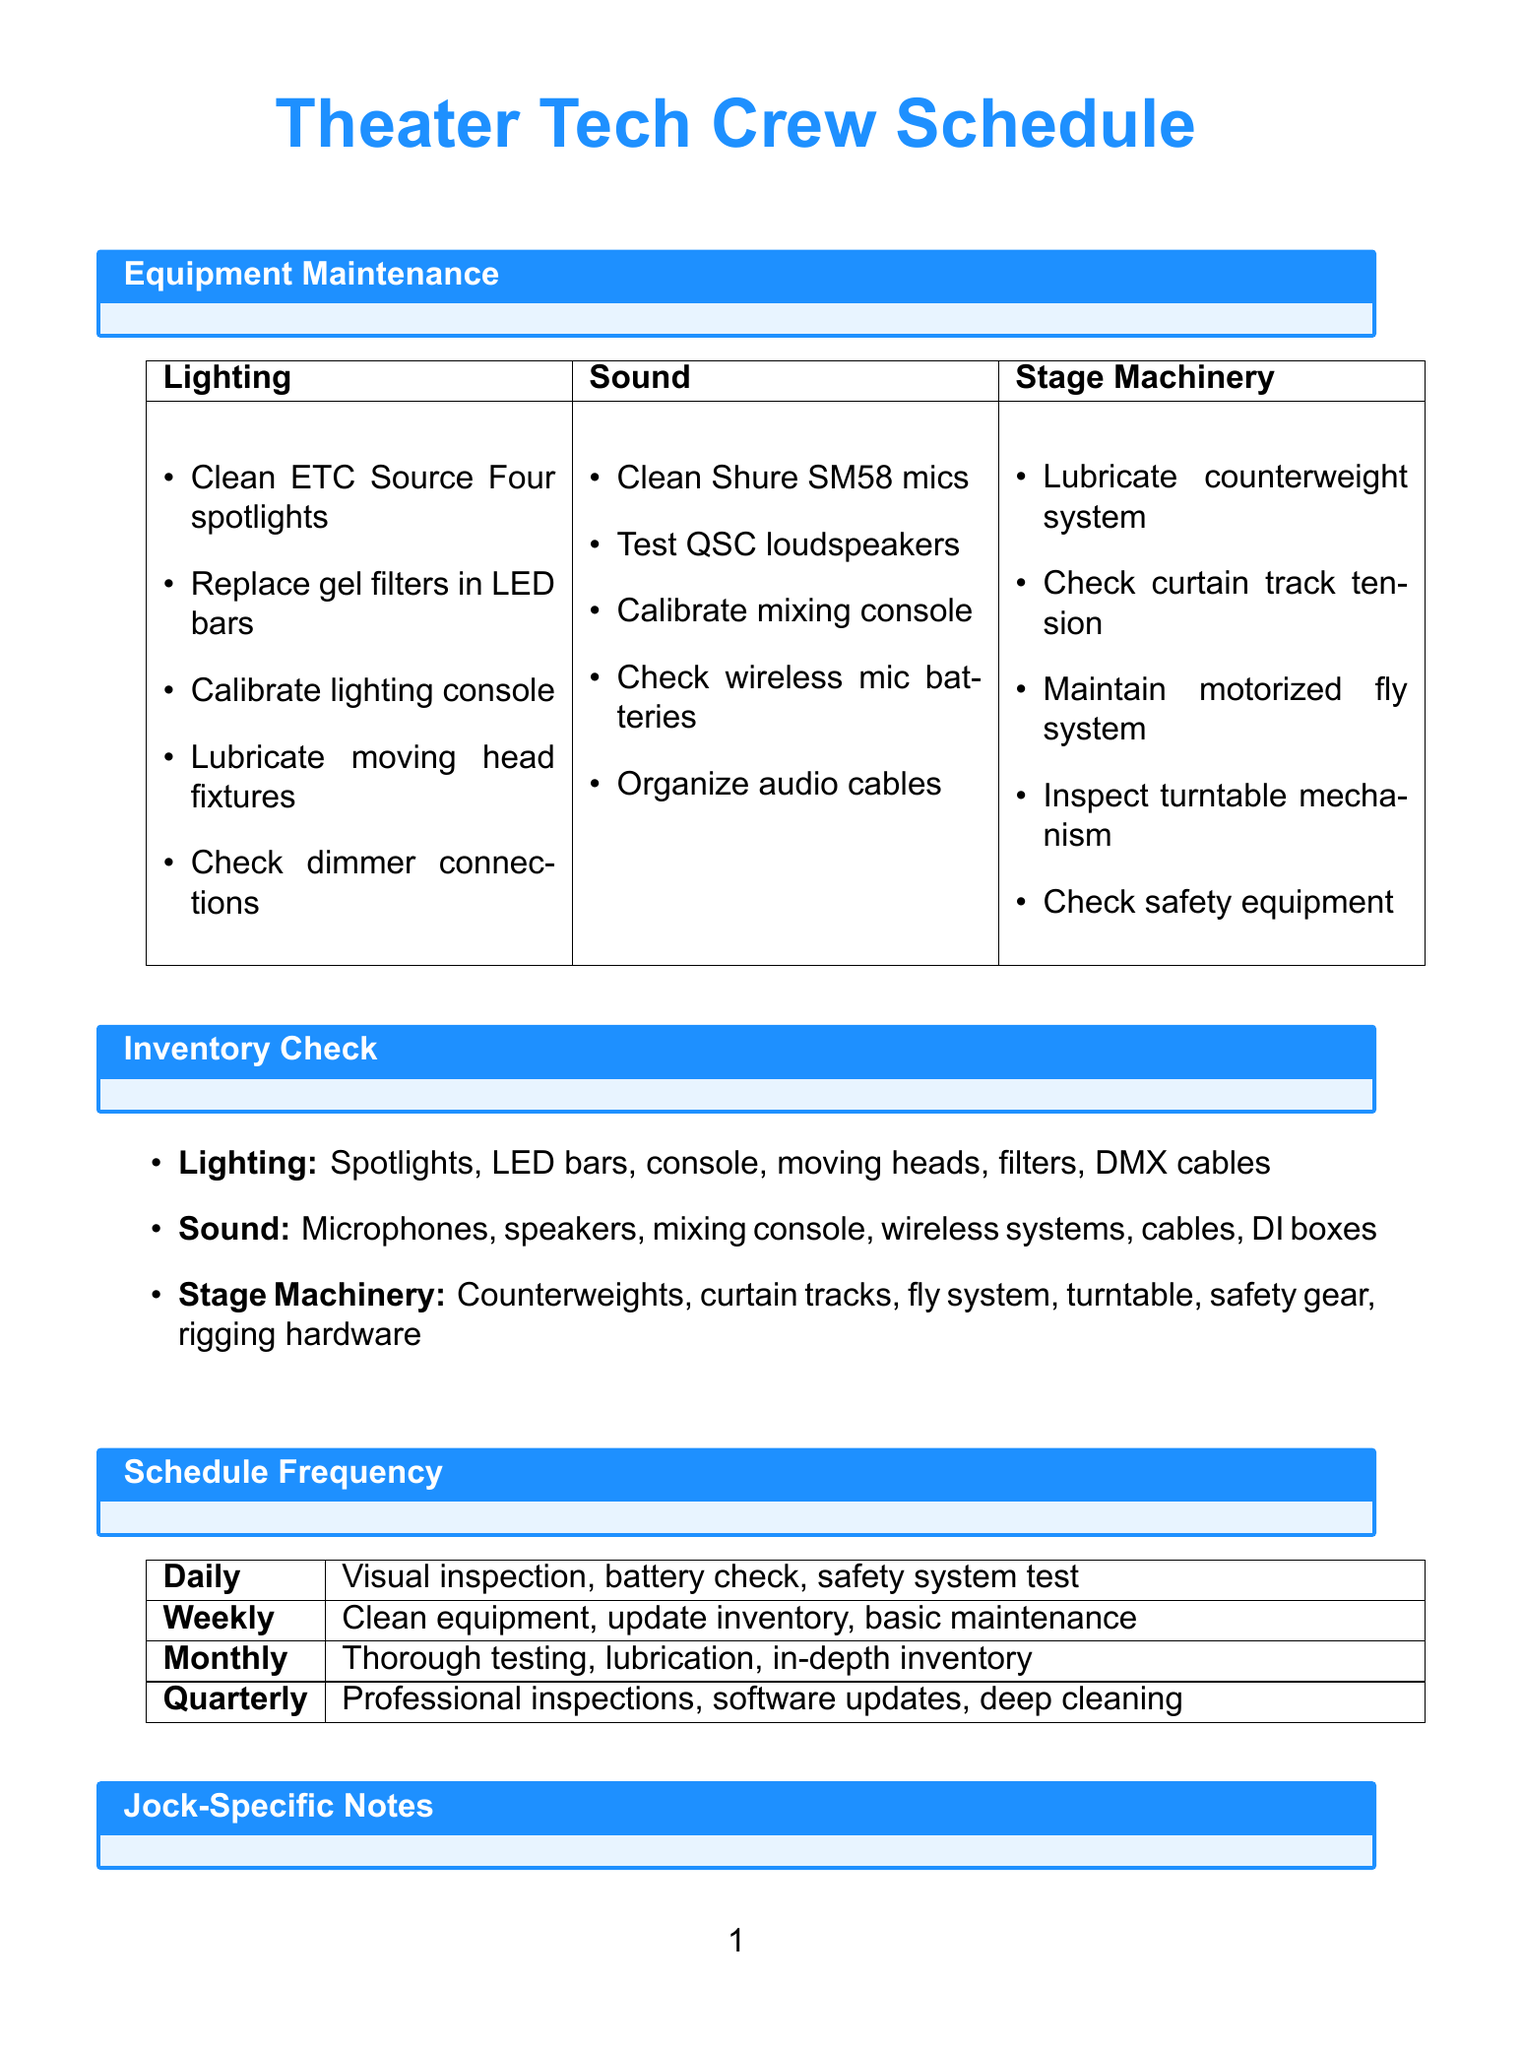What are the four categories of equipment? The document lists three categories of equipment as Lighting, Sound, and Stage Machinery.
Answer: Lighting, Sound, Stage Machinery How often is a visual inspection conducted? The document states that visual inspections are part of the daily schedule.
Answer: Daily What task is listed for sound maintenance? One of the tasks listed for sound maintenance is to test and clean Shure SM58 microphones.
Answer: Test and clean Shure SM58 microphones Which safety procedure involves electrical equipment? The procedures include following lockout/tagout procedures for electrical equipment.
Answer: Lockout/tagout procedures What inventory item is associated with the stage machinery category? The document lists safety harnesses and carabiners as inventory items for stage machinery.
Answer: Safety harnesses and carabiners How frequently are thorough equipment testing and calibration scheduled? Thorough equipment testing and calibration tasks are scheduled monthly.
Answer: Monthly What is a jock-specific note related to sports practice? One jock-specific note mentions to coordinate equipment maintenance around sports practice schedule.
Answer: Coordinate equipment maintenance around sports practice Which technician is responsible for mixing live performances? The sound engineer is responsible for mixing live performances.
Answer: Sound engineer What is a daily maintenance task for lighting? One daily task for lighting maintenance is to perform a visual inspection of all equipment.
Answer: Visual inspection of all equipment 